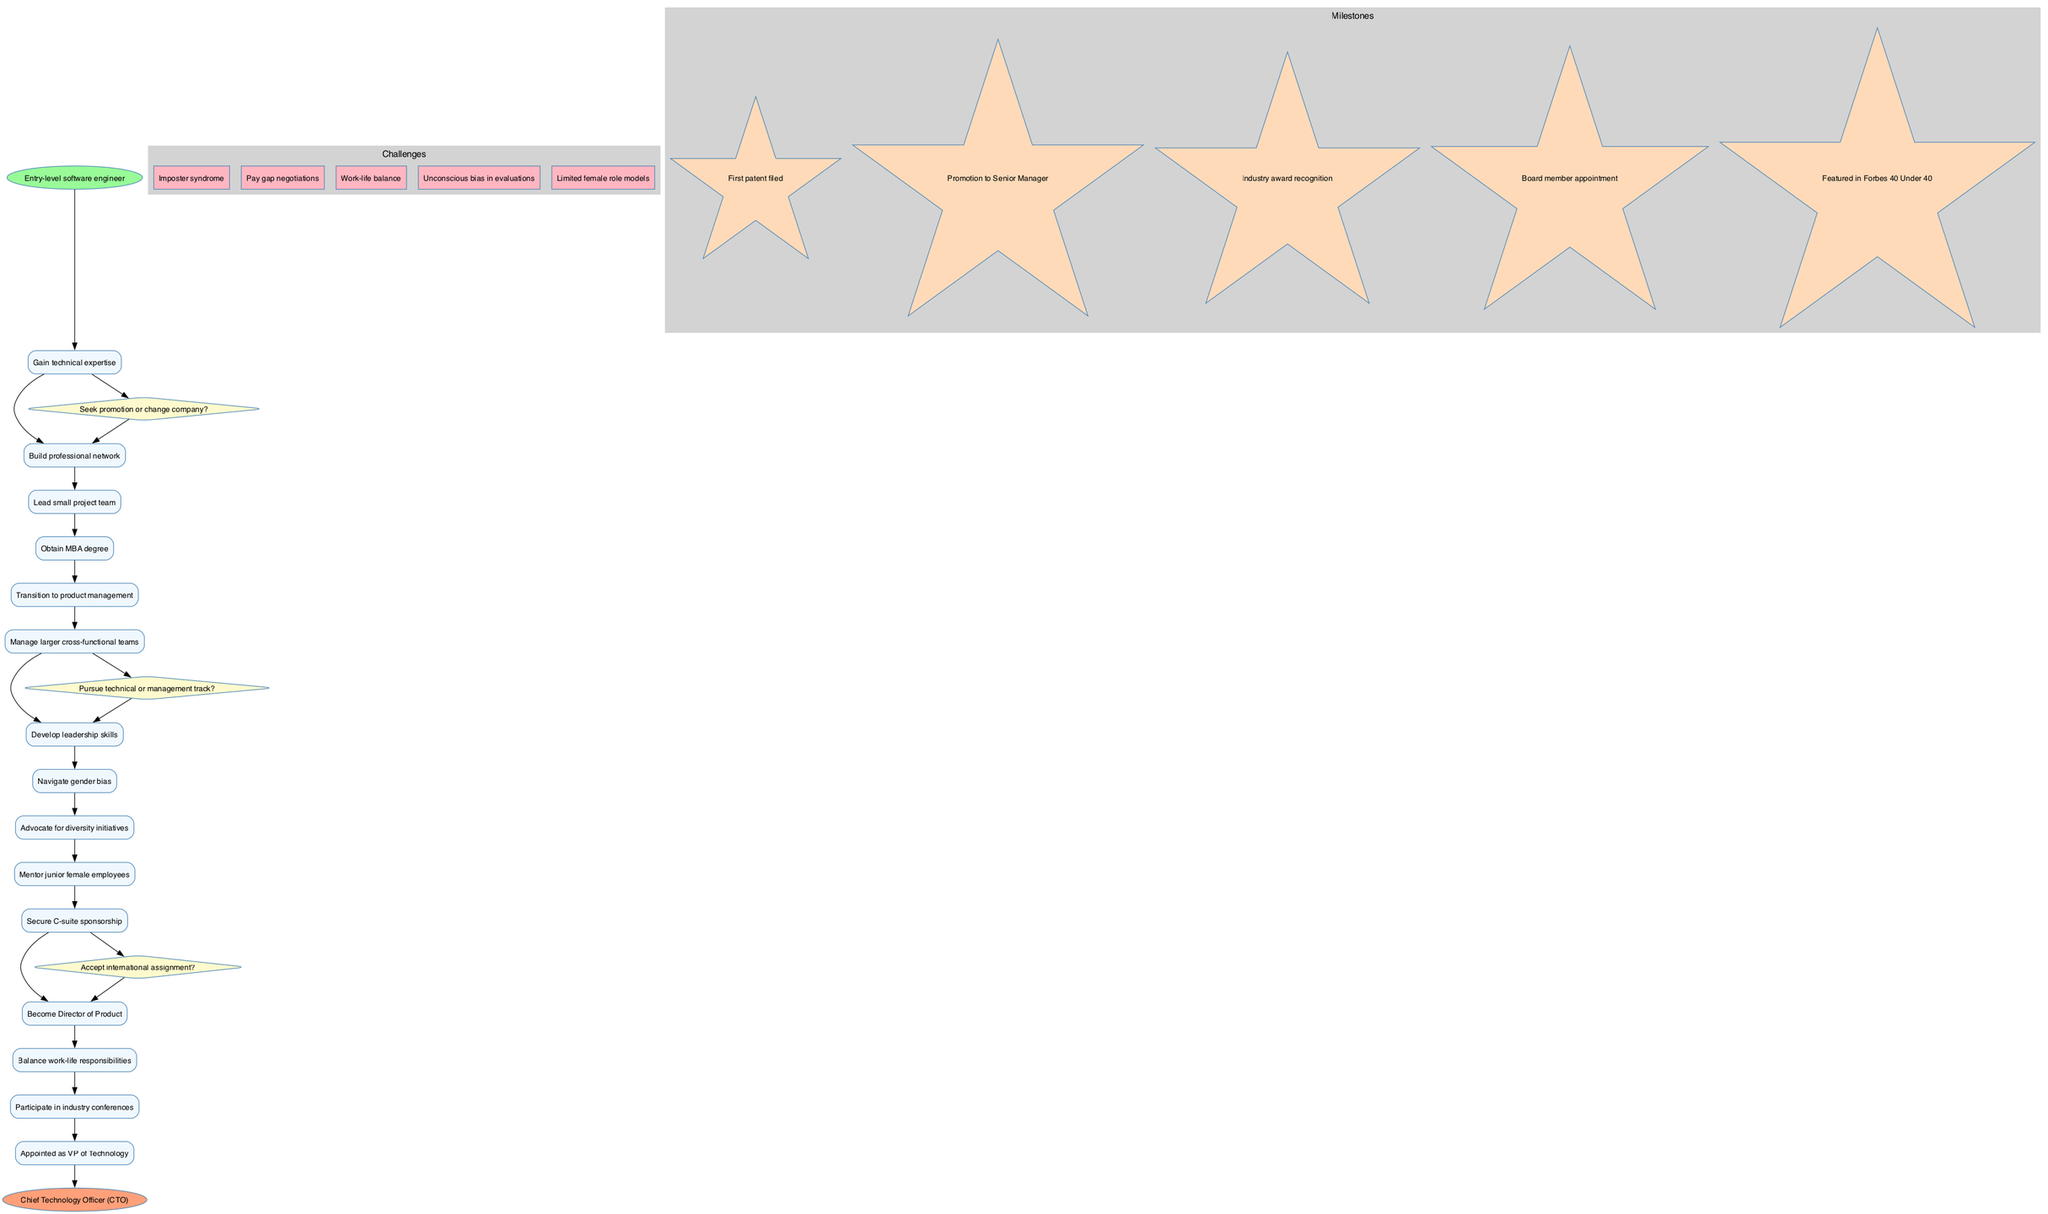What is the start node of the diagram? The start node is identified clearly as "Entry-level software engineer." It's the first node that initiates the flow of activities in the diagram.
Answer: Entry-level software engineer How many decision points are there in the diagram? The diagram includes three distinct decision points, which can be summarized as the choices to seek promotion, pursue a track, and accept assignments. Each is represented in the shape of a diamond.
Answer: 3 What is the last activity before reaching the end node? The last activity in the sequence before reaching the end node is "Appointed as VP of Technology." This is the final milestone achieved prior to the conclusion of the diagram's progression.
Answer: Appointed as VP of Technology Which challenge is related to performance evaluations? "Unconscious bias in evaluations" is the challenge that pertains directly to performance evaluations and how gender bias can influence perceptions and results.
Answer: Unconscious bias in evaluations What milestone is represented as a star in the diagram? The milestone "Featured in Forbes 40 Under 40" is depicted as a star, indicating its significance as a recognition marker within the career progression shown in the diagram.
Answer: Featured in Forbes 40 Under 40 If a decision is made to pursue the management track, what will be the next activity? If the decision is made to pursue the management track, the subsequent activity will be "Obtain MBA degree." This is indicated directly following the decision point related to the management track.
Answer: Obtain MBA degree What is the relationship between "Manage larger cross-functional teams" and "Develop leadership skills"? The activity "Develop leadership skills" directly follows "Manage larger cross-functional teams," indicating a sequential flow where managing teams is likely a precursor to developing leadership abilities.
Answer: Develop leadership skills What is the end node of the diagram? The end node is clearly stated as "Chief Technology Officer (CTO)," which represents the ultimate position achieved in this career progression.
Answer: Chief Technology Officer (CTO) 